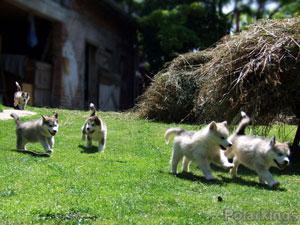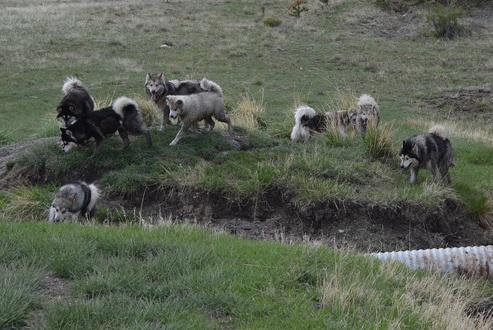The first image is the image on the left, the second image is the image on the right. For the images displayed, is the sentence "There are dogs with sheep in each image" factually correct? Answer yes or no. No. The first image is the image on the left, the second image is the image on the right. Analyze the images presented: Is the assertion "there are at least 6 husky dogs on a grassy hill" valid? Answer yes or no. Yes. 